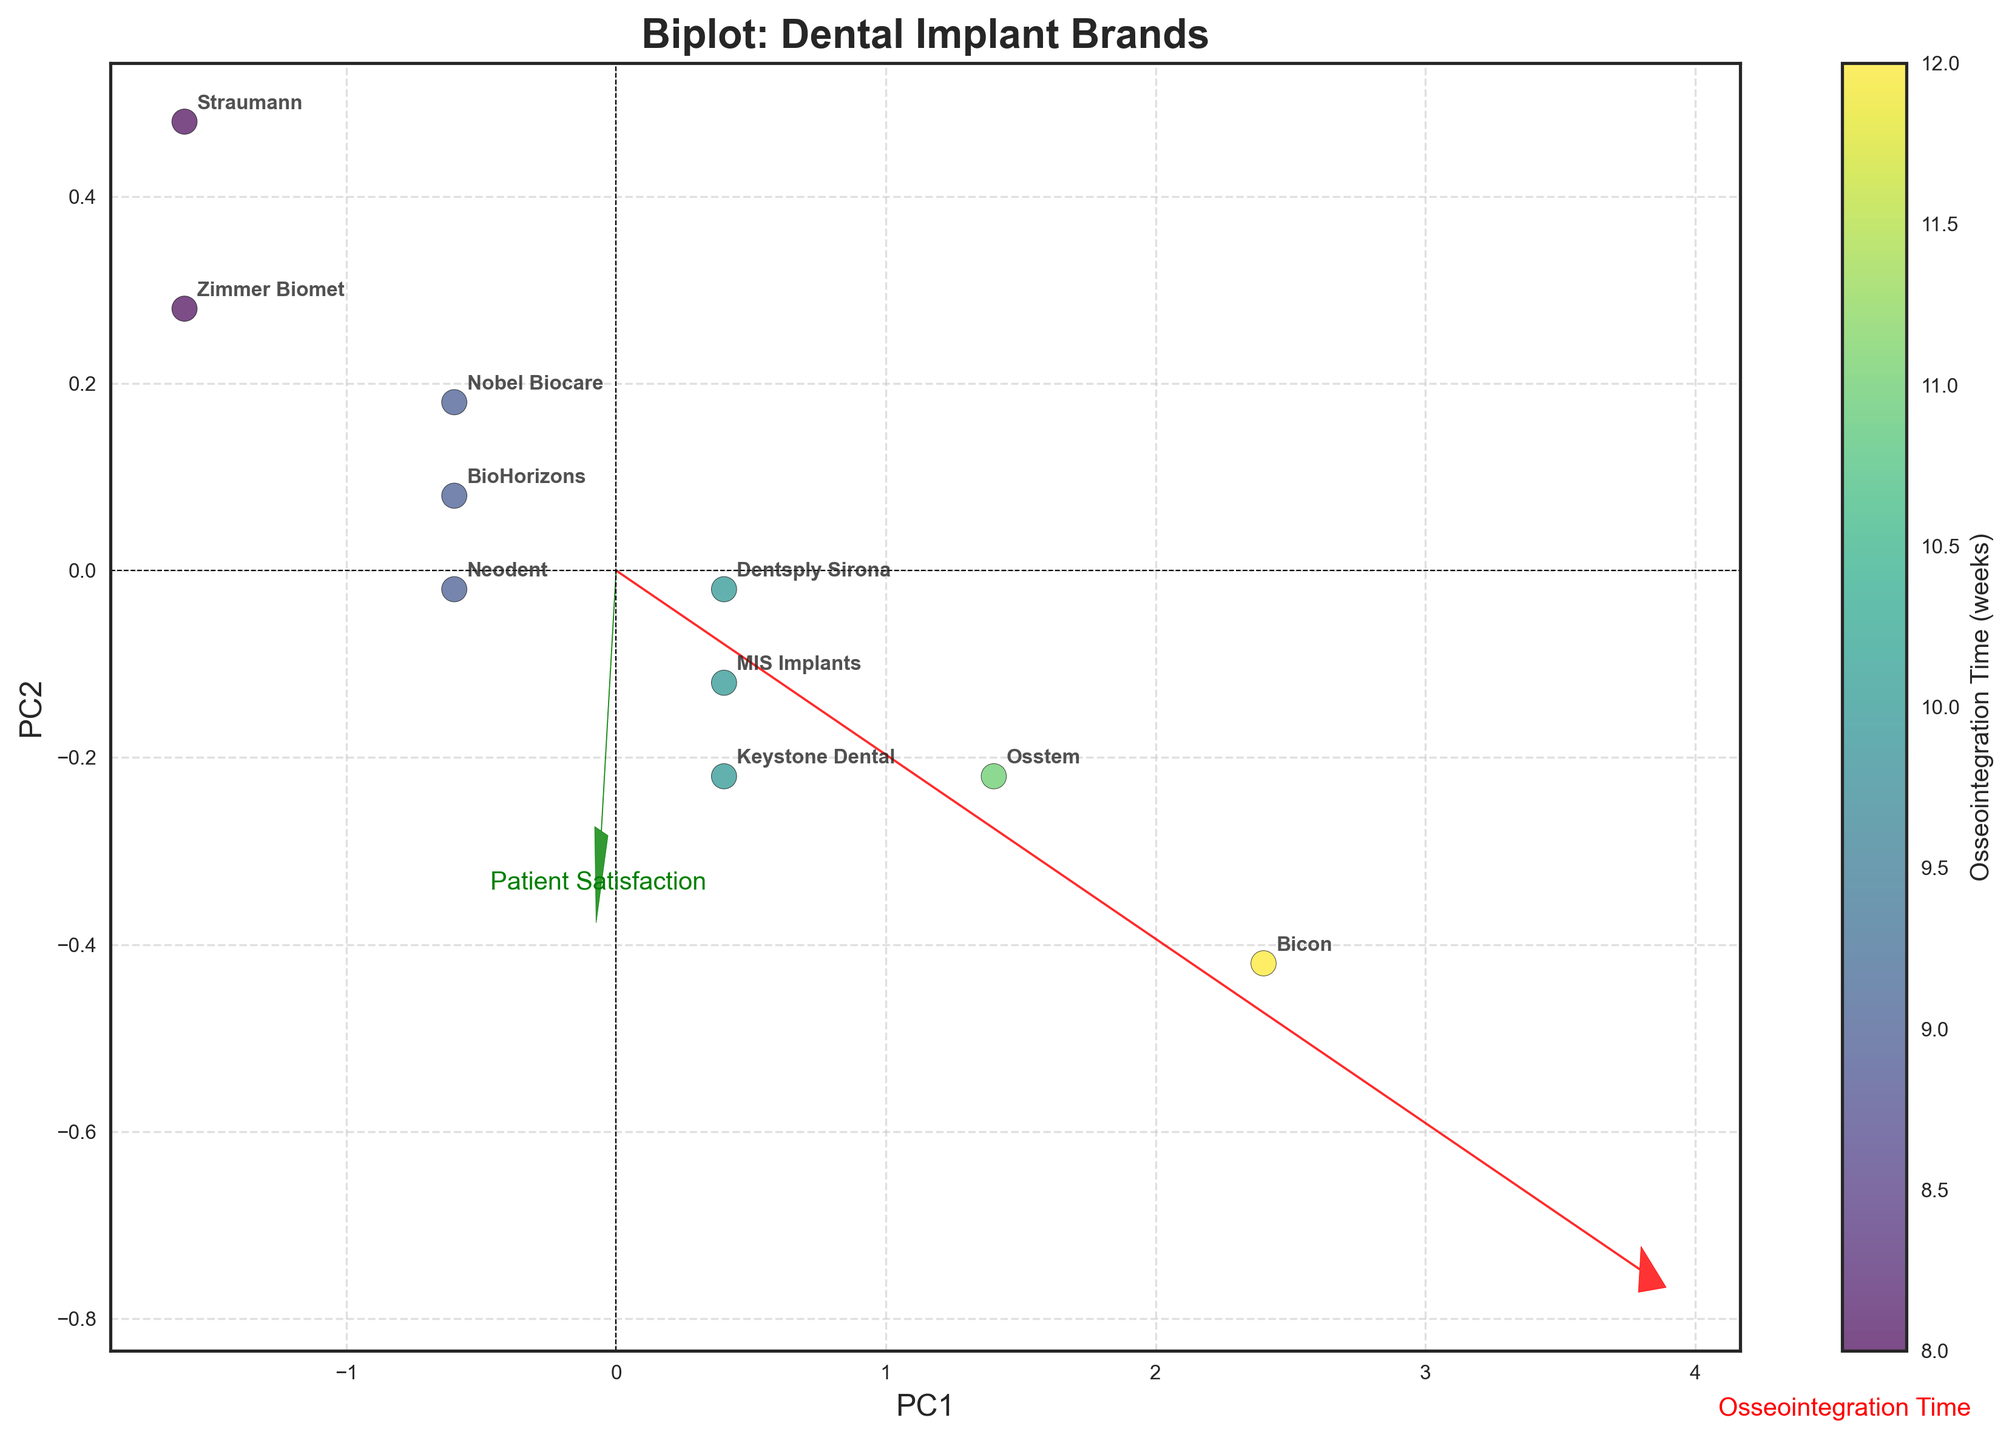What is the title of the biplot? The title is usually at the top of the figure and denotes the main subject or focus. The title of this biplot states "Biplot: Dental Implant Brands".
Answer: Biplot: Dental Implant Brands Which implant brand shows the highest patient satisfaction? By looking at the y-axis (Patient Satisfaction), the point positioned highest on this axis represents the brand with the highest satisfaction score. Straumann has the highest position on the y-axis with a score of 9.2.
Answer: Straumann What does the color gradient in the scatter points represent? The color gradient typically correlates with a measure shown in the color bar, which is labeled as "Osseointegration Time (weeks)". This indicates the osseointegration time for each implant brand.
Answer: Osseointegration Time (weeks) How many implant brands have an osseointegration time of 9 weeks? Identify the scatter points that match the color indicative of 9 weeks as per the color bar. There are three brands at 9 weeks: Nobel Biocare, BioHorizons, and Neodent.
Answer: Three What feature vectors are displayed on the biplot? These vectors are usually arrows that represent the original variables in the PCA transformed space. The biplot shows two feature vectors labeled as 'Osseointegration Time' and 'Patient Satisfaction'.
Answer: Osseointegration Time, Patient Satisfaction Which implant brand has the longest osseointegration time and what is its patient satisfaction score? Locate the point furthest on the x-axis representing osseointegration time and note its corresponding y-axis value. Bicon has the longest osseointegration time of 12 weeks and a satisfaction score of 8.3.
Answer: Bicon, Satisfaction: 8.3 Compare Straumann and Osstem in terms of patient satisfaction. Which one has a higher satisfaction score and by how much? Find the y-values for Straumann (9.2) and Osstem (8.5) and calculate the difference. Straumann has a higher satisfaction score by 0.7.
Answer: Straumann, by 0.7 Which implant brand is most aligned with the 'Patient Satisfaction' vector? Identify the point that lies closest along the direction of the 'Patient Satisfaction' arrow. Straumann aligns most closely with the 'Patient Satisfaction' vector.
Answer: Straumann What is the relationship between osseointegration time and patient satisfaction for the implant brand Bicon? Locate the position of Bicon in the plot. Bicon has an osseointegration time of 12 weeks and a satisfaction score of 8.3, indicating that higher osseointegration time is associated with lower satisfaction in this case.
Answer: Higher osseointegration time, lower satisfaction for Bicon Among the brands Zimmer Biomet, BioHorizons, and Keystone Dental, which has the highest patient satisfaction? Compare their positions on the y-axis (Patient Satisfaction). Zimmer Biomet (9.0) has the highest satisfaction score among the three.
Answer: Zimmer Biomet 